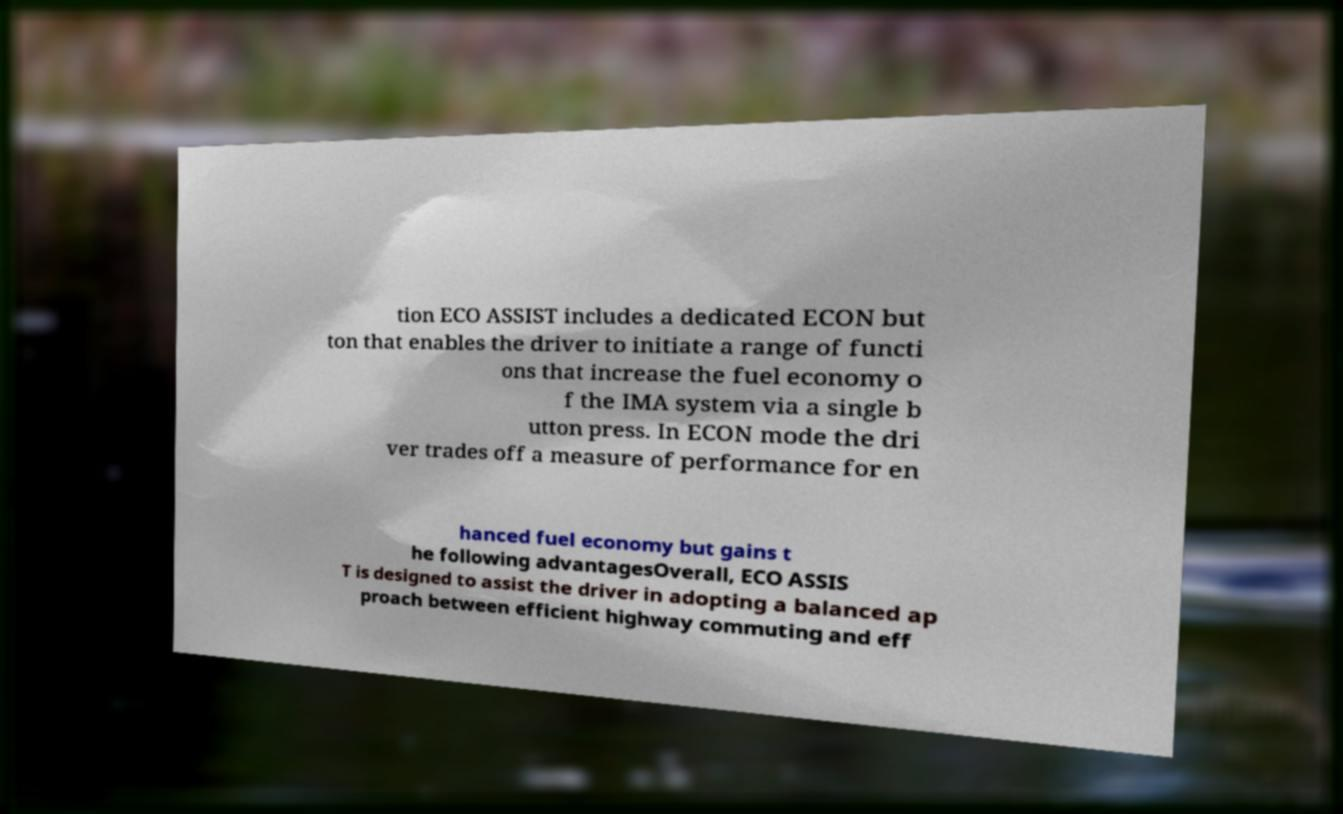What messages or text are displayed in this image? I need them in a readable, typed format. tion ECO ASSIST includes a dedicated ECON but ton that enables the driver to initiate a range of functi ons that increase the fuel economy o f the IMA system via a single b utton press. In ECON mode the dri ver trades off a measure of performance for en hanced fuel economy but gains t he following advantagesOverall, ECO ASSIS T is designed to assist the driver in adopting a balanced ap proach between efficient highway commuting and eff 